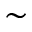Convert formula to latex. <formula><loc_0><loc_0><loc_500><loc_500>\sim</formula> 